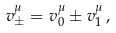<formula> <loc_0><loc_0><loc_500><loc_500>v ^ { \mu } _ { \pm } = v ^ { \mu } _ { 0 } \pm v ^ { \mu } _ { 1 } \, ,</formula> 